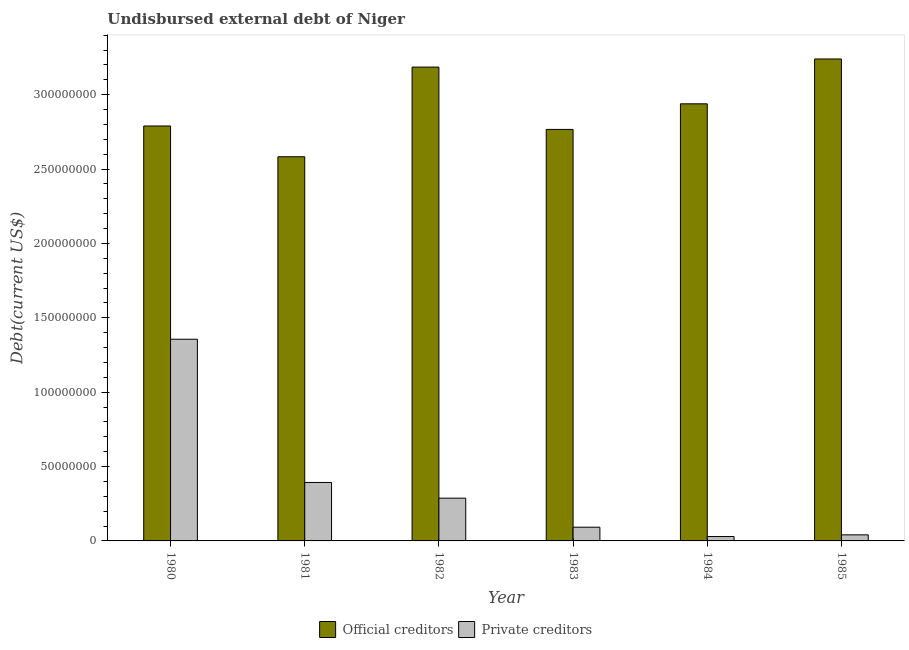How many groups of bars are there?
Give a very brief answer. 6. What is the label of the 2nd group of bars from the left?
Keep it short and to the point. 1981. What is the undisbursed external debt of private creditors in 1985?
Your answer should be very brief. 4.08e+06. Across all years, what is the maximum undisbursed external debt of official creditors?
Provide a short and direct response. 3.24e+08. Across all years, what is the minimum undisbursed external debt of private creditors?
Offer a very short reply. 2.96e+06. In which year was the undisbursed external debt of official creditors minimum?
Offer a very short reply. 1981. What is the total undisbursed external debt of private creditors in the graph?
Offer a very short reply. 2.20e+08. What is the difference between the undisbursed external debt of official creditors in 1983 and that in 1985?
Provide a short and direct response. -4.74e+07. What is the difference between the undisbursed external debt of private creditors in 1985 and the undisbursed external debt of official creditors in 1983?
Your response must be concise. -5.14e+06. What is the average undisbursed external debt of private creditors per year?
Make the answer very short. 3.67e+07. What is the ratio of the undisbursed external debt of official creditors in 1982 to that in 1984?
Your answer should be compact. 1.08. Is the undisbursed external debt of official creditors in 1980 less than that in 1983?
Your response must be concise. No. What is the difference between the highest and the second highest undisbursed external debt of private creditors?
Your response must be concise. 9.63e+07. What is the difference between the highest and the lowest undisbursed external debt of private creditors?
Offer a terse response. 1.33e+08. In how many years, is the undisbursed external debt of official creditors greater than the average undisbursed external debt of official creditors taken over all years?
Make the answer very short. 3. Is the sum of the undisbursed external debt of official creditors in 1980 and 1982 greater than the maximum undisbursed external debt of private creditors across all years?
Keep it short and to the point. Yes. What does the 2nd bar from the left in 1983 represents?
Offer a terse response. Private creditors. What does the 1st bar from the right in 1980 represents?
Make the answer very short. Private creditors. Are the values on the major ticks of Y-axis written in scientific E-notation?
Provide a succinct answer. No. Where does the legend appear in the graph?
Your answer should be compact. Bottom center. What is the title of the graph?
Offer a terse response. Undisbursed external debt of Niger. What is the label or title of the Y-axis?
Your response must be concise. Debt(current US$). What is the Debt(current US$) in Official creditors in 1980?
Keep it short and to the point. 2.79e+08. What is the Debt(current US$) of Private creditors in 1980?
Keep it short and to the point. 1.36e+08. What is the Debt(current US$) of Official creditors in 1981?
Your answer should be very brief. 2.58e+08. What is the Debt(current US$) in Private creditors in 1981?
Keep it short and to the point. 3.93e+07. What is the Debt(current US$) in Official creditors in 1982?
Give a very brief answer. 3.19e+08. What is the Debt(current US$) in Private creditors in 1982?
Your response must be concise. 2.88e+07. What is the Debt(current US$) of Official creditors in 1983?
Provide a succinct answer. 2.77e+08. What is the Debt(current US$) of Private creditors in 1983?
Make the answer very short. 9.22e+06. What is the Debt(current US$) in Official creditors in 1984?
Ensure brevity in your answer.  2.94e+08. What is the Debt(current US$) in Private creditors in 1984?
Provide a short and direct response. 2.96e+06. What is the Debt(current US$) of Official creditors in 1985?
Provide a short and direct response. 3.24e+08. What is the Debt(current US$) in Private creditors in 1985?
Your response must be concise. 4.08e+06. Across all years, what is the maximum Debt(current US$) in Official creditors?
Ensure brevity in your answer.  3.24e+08. Across all years, what is the maximum Debt(current US$) of Private creditors?
Provide a short and direct response. 1.36e+08. Across all years, what is the minimum Debt(current US$) in Official creditors?
Give a very brief answer. 2.58e+08. Across all years, what is the minimum Debt(current US$) of Private creditors?
Keep it short and to the point. 2.96e+06. What is the total Debt(current US$) of Official creditors in the graph?
Your answer should be compact. 1.75e+09. What is the total Debt(current US$) of Private creditors in the graph?
Your answer should be very brief. 2.20e+08. What is the difference between the Debt(current US$) of Official creditors in 1980 and that in 1981?
Your answer should be compact. 2.07e+07. What is the difference between the Debt(current US$) of Private creditors in 1980 and that in 1981?
Your response must be concise. 9.63e+07. What is the difference between the Debt(current US$) in Official creditors in 1980 and that in 1982?
Offer a very short reply. -3.96e+07. What is the difference between the Debt(current US$) in Private creditors in 1980 and that in 1982?
Give a very brief answer. 1.07e+08. What is the difference between the Debt(current US$) in Official creditors in 1980 and that in 1983?
Your answer should be very brief. 2.31e+06. What is the difference between the Debt(current US$) in Private creditors in 1980 and that in 1983?
Provide a short and direct response. 1.26e+08. What is the difference between the Debt(current US$) in Official creditors in 1980 and that in 1984?
Provide a short and direct response. -1.49e+07. What is the difference between the Debt(current US$) in Private creditors in 1980 and that in 1984?
Provide a succinct answer. 1.33e+08. What is the difference between the Debt(current US$) of Official creditors in 1980 and that in 1985?
Give a very brief answer. -4.51e+07. What is the difference between the Debt(current US$) of Private creditors in 1980 and that in 1985?
Your answer should be very brief. 1.32e+08. What is the difference between the Debt(current US$) in Official creditors in 1981 and that in 1982?
Give a very brief answer. -6.03e+07. What is the difference between the Debt(current US$) in Private creditors in 1981 and that in 1982?
Your answer should be compact. 1.06e+07. What is the difference between the Debt(current US$) in Official creditors in 1981 and that in 1983?
Your answer should be very brief. -1.84e+07. What is the difference between the Debt(current US$) in Private creditors in 1981 and that in 1983?
Offer a very short reply. 3.01e+07. What is the difference between the Debt(current US$) in Official creditors in 1981 and that in 1984?
Offer a terse response. -3.56e+07. What is the difference between the Debt(current US$) of Private creditors in 1981 and that in 1984?
Your response must be concise. 3.64e+07. What is the difference between the Debt(current US$) of Official creditors in 1981 and that in 1985?
Give a very brief answer. -6.57e+07. What is the difference between the Debt(current US$) of Private creditors in 1981 and that in 1985?
Offer a terse response. 3.52e+07. What is the difference between the Debt(current US$) of Official creditors in 1982 and that in 1983?
Make the answer very short. 4.19e+07. What is the difference between the Debt(current US$) of Private creditors in 1982 and that in 1983?
Keep it short and to the point. 1.95e+07. What is the difference between the Debt(current US$) of Official creditors in 1982 and that in 1984?
Your response must be concise. 2.47e+07. What is the difference between the Debt(current US$) of Private creditors in 1982 and that in 1984?
Your answer should be compact. 2.58e+07. What is the difference between the Debt(current US$) of Official creditors in 1982 and that in 1985?
Provide a short and direct response. -5.45e+06. What is the difference between the Debt(current US$) in Private creditors in 1982 and that in 1985?
Your answer should be compact. 2.47e+07. What is the difference between the Debt(current US$) of Official creditors in 1983 and that in 1984?
Your answer should be compact. -1.72e+07. What is the difference between the Debt(current US$) in Private creditors in 1983 and that in 1984?
Give a very brief answer. 6.26e+06. What is the difference between the Debt(current US$) in Official creditors in 1983 and that in 1985?
Provide a succinct answer. -4.74e+07. What is the difference between the Debt(current US$) in Private creditors in 1983 and that in 1985?
Provide a short and direct response. 5.14e+06. What is the difference between the Debt(current US$) in Official creditors in 1984 and that in 1985?
Your response must be concise. -3.02e+07. What is the difference between the Debt(current US$) in Private creditors in 1984 and that in 1985?
Give a very brief answer. -1.12e+06. What is the difference between the Debt(current US$) in Official creditors in 1980 and the Debt(current US$) in Private creditors in 1981?
Your response must be concise. 2.40e+08. What is the difference between the Debt(current US$) of Official creditors in 1980 and the Debt(current US$) of Private creditors in 1982?
Make the answer very short. 2.50e+08. What is the difference between the Debt(current US$) in Official creditors in 1980 and the Debt(current US$) in Private creditors in 1983?
Your answer should be very brief. 2.70e+08. What is the difference between the Debt(current US$) of Official creditors in 1980 and the Debt(current US$) of Private creditors in 1984?
Your response must be concise. 2.76e+08. What is the difference between the Debt(current US$) of Official creditors in 1980 and the Debt(current US$) of Private creditors in 1985?
Give a very brief answer. 2.75e+08. What is the difference between the Debt(current US$) of Official creditors in 1981 and the Debt(current US$) of Private creditors in 1982?
Your answer should be compact. 2.30e+08. What is the difference between the Debt(current US$) of Official creditors in 1981 and the Debt(current US$) of Private creditors in 1983?
Give a very brief answer. 2.49e+08. What is the difference between the Debt(current US$) in Official creditors in 1981 and the Debt(current US$) in Private creditors in 1984?
Keep it short and to the point. 2.55e+08. What is the difference between the Debt(current US$) in Official creditors in 1981 and the Debt(current US$) in Private creditors in 1985?
Provide a succinct answer. 2.54e+08. What is the difference between the Debt(current US$) in Official creditors in 1982 and the Debt(current US$) in Private creditors in 1983?
Keep it short and to the point. 3.09e+08. What is the difference between the Debt(current US$) of Official creditors in 1982 and the Debt(current US$) of Private creditors in 1984?
Keep it short and to the point. 3.16e+08. What is the difference between the Debt(current US$) of Official creditors in 1982 and the Debt(current US$) of Private creditors in 1985?
Give a very brief answer. 3.15e+08. What is the difference between the Debt(current US$) in Official creditors in 1983 and the Debt(current US$) in Private creditors in 1984?
Keep it short and to the point. 2.74e+08. What is the difference between the Debt(current US$) of Official creditors in 1983 and the Debt(current US$) of Private creditors in 1985?
Offer a very short reply. 2.73e+08. What is the difference between the Debt(current US$) of Official creditors in 1984 and the Debt(current US$) of Private creditors in 1985?
Your answer should be very brief. 2.90e+08. What is the average Debt(current US$) of Official creditors per year?
Give a very brief answer. 2.92e+08. What is the average Debt(current US$) in Private creditors per year?
Your answer should be compact. 3.67e+07. In the year 1980, what is the difference between the Debt(current US$) in Official creditors and Debt(current US$) in Private creditors?
Give a very brief answer. 1.43e+08. In the year 1981, what is the difference between the Debt(current US$) of Official creditors and Debt(current US$) of Private creditors?
Give a very brief answer. 2.19e+08. In the year 1982, what is the difference between the Debt(current US$) in Official creditors and Debt(current US$) in Private creditors?
Your answer should be very brief. 2.90e+08. In the year 1983, what is the difference between the Debt(current US$) in Official creditors and Debt(current US$) in Private creditors?
Make the answer very short. 2.67e+08. In the year 1984, what is the difference between the Debt(current US$) of Official creditors and Debt(current US$) of Private creditors?
Your response must be concise. 2.91e+08. In the year 1985, what is the difference between the Debt(current US$) of Official creditors and Debt(current US$) of Private creditors?
Ensure brevity in your answer.  3.20e+08. What is the ratio of the Debt(current US$) in Official creditors in 1980 to that in 1981?
Your answer should be compact. 1.08. What is the ratio of the Debt(current US$) of Private creditors in 1980 to that in 1981?
Provide a short and direct response. 3.45. What is the ratio of the Debt(current US$) in Official creditors in 1980 to that in 1982?
Make the answer very short. 0.88. What is the ratio of the Debt(current US$) of Private creditors in 1980 to that in 1982?
Offer a terse response. 4.72. What is the ratio of the Debt(current US$) of Official creditors in 1980 to that in 1983?
Make the answer very short. 1.01. What is the ratio of the Debt(current US$) of Private creditors in 1980 to that in 1983?
Your answer should be very brief. 14.7. What is the ratio of the Debt(current US$) of Official creditors in 1980 to that in 1984?
Your answer should be very brief. 0.95. What is the ratio of the Debt(current US$) in Private creditors in 1980 to that in 1984?
Make the answer very short. 45.83. What is the ratio of the Debt(current US$) in Official creditors in 1980 to that in 1985?
Offer a very short reply. 0.86. What is the ratio of the Debt(current US$) in Private creditors in 1980 to that in 1985?
Ensure brevity in your answer.  33.22. What is the ratio of the Debt(current US$) of Official creditors in 1981 to that in 1982?
Offer a very short reply. 0.81. What is the ratio of the Debt(current US$) in Private creditors in 1981 to that in 1982?
Provide a short and direct response. 1.37. What is the ratio of the Debt(current US$) in Official creditors in 1981 to that in 1983?
Keep it short and to the point. 0.93. What is the ratio of the Debt(current US$) of Private creditors in 1981 to that in 1983?
Give a very brief answer. 4.26. What is the ratio of the Debt(current US$) of Official creditors in 1981 to that in 1984?
Your response must be concise. 0.88. What is the ratio of the Debt(current US$) of Private creditors in 1981 to that in 1984?
Offer a very short reply. 13.29. What is the ratio of the Debt(current US$) in Official creditors in 1981 to that in 1985?
Your answer should be compact. 0.8. What is the ratio of the Debt(current US$) of Private creditors in 1981 to that in 1985?
Make the answer very short. 9.63. What is the ratio of the Debt(current US$) of Official creditors in 1982 to that in 1983?
Your answer should be very brief. 1.15. What is the ratio of the Debt(current US$) of Private creditors in 1982 to that in 1983?
Give a very brief answer. 3.12. What is the ratio of the Debt(current US$) of Official creditors in 1982 to that in 1984?
Offer a terse response. 1.08. What is the ratio of the Debt(current US$) in Private creditors in 1982 to that in 1984?
Provide a short and direct response. 9.72. What is the ratio of the Debt(current US$) of Official creditors in 1982 to that in 1985?
Your answer should be very brief. 0.98. What is the ratio of the Debt(current US$) of Private creditors in 1982 to that in 1985?
Provide a succinct answer. 7.04. What is the ratio of the Debt(current US$) in Official creditors in 1983 to that in 1984?
Make the answer very short. 0.94. What is the ratio of the Debt(current US$) of Private creditors in 1983 to that in 1984?
Your answer should be very brief. 3.12. What is the ratio of the Debt(current US$) of Official creditors in 1983 to that in 1985?
Keep it short and to the point. 0.85. What is the ratio of the Debt(current US$) in Private creditors in 1983 to that in 1985?
Your answer should be compact. 2.26. What is the ratio of the Debt(current US$) in Official creditors in 1984 to that in 1985?
Your response must be concise. 0.91. What is the ratio of the Debt(current US$) in Private creditors in 1984 to that in 1985?
Make the answer very short. 0.72. What is the difference between the highest and the second highest Debt(current US$) of Official creditors?
Keep it short and to the point. 5.45e+06. What is the difference between the highest and the second highest Debt(current US$) in Private creditors?
Provide a succinct answer. 9.63e+07. What is the difference between the highest and the lowest Debt(current US$) in Official creditors?
Your response must be concise. 6.57e+07. What is the difference between the highest and the lowest Debt(current US$) of Private creditors?
Give a very brief answer. 1.33e+08. 